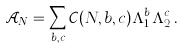Convert formula to latex. <formula><loc_0><loc_0><loc_500><loc_500>\mathcal { A } _ { N } = \sum _ { b , c } \mathcal { C } ( N , b , c ) \Lambda _ { 1 } ^ { b } \Lambda _ { 2 } ^ { c } \, .</formula> 